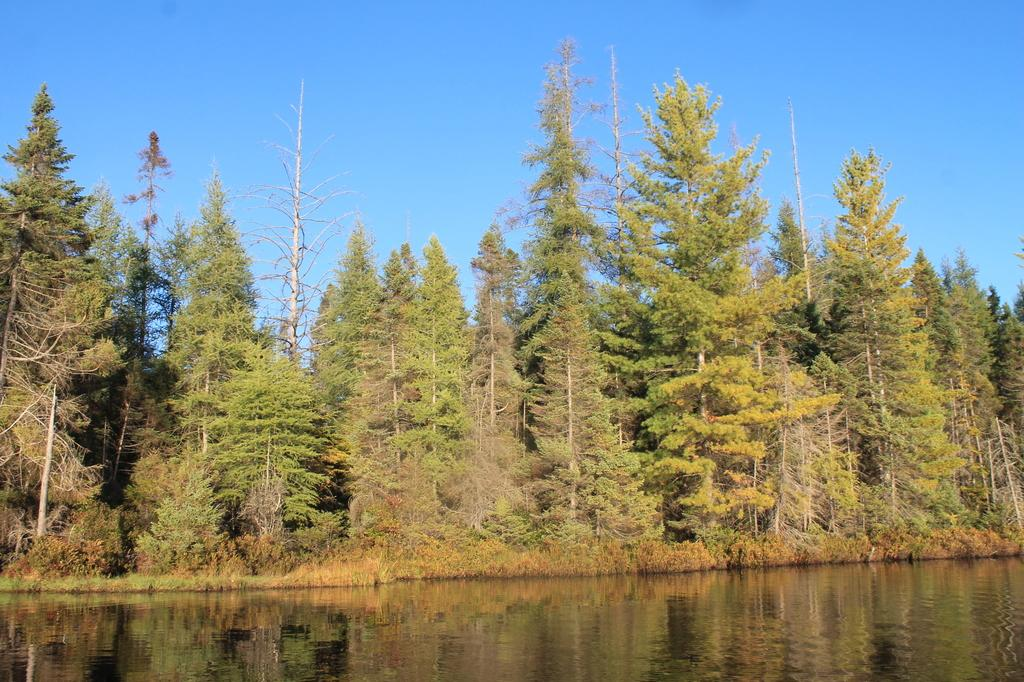What type of vegetation can be seen in the image? There are trees in the image. What body of water is present at the bottom of the image? There is a lake at the bottom of the image. What part of the natural environment is visible in the background of the image? The sky is visible in the background of the image. How many icicles are hanging from the trees in the image? There are no icicles present in the image, as it features trees and a lake in a natural setting. What decision was made by the lake in the image? The lake in the image is a body of water and does not make decisions. 